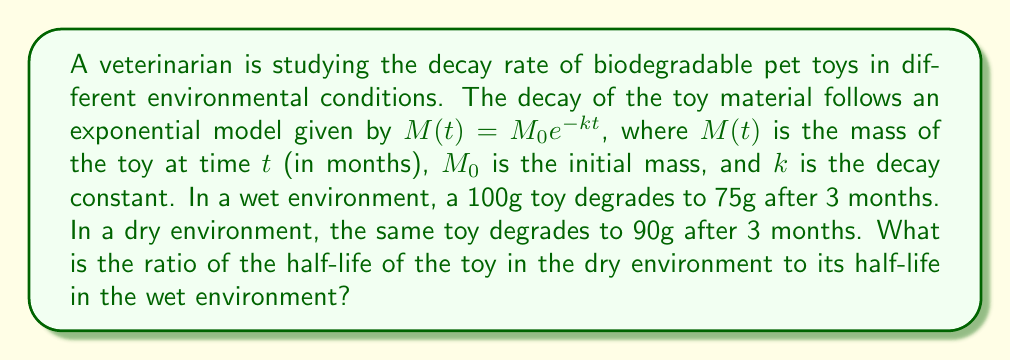Help me with this question. Let's approach this step-by-step:

1) First, we need to find the decay constants ($k$) for both environments.

2) For the wet environment:
   $75 = 100e^{-k_w \cdot 3}$
   $\ln(0.75) = -3k_w$
   $k_w = -\frac{\ln(0.75)}{3} \approx 0.0963$

3) For the dry environment:
   $90 = 100e^{-k_d \cdot 3}$
   $\ln(0.9) = -3k_d$
   $k_d = -\frac{\ln(0.9)}{3} \approx 0.0351$

4) The half-life ($t_{1/2}$) is the time it takes for half of the material to decay. It's given by:
   $t_{1/2} = \frac{\ln(2)}{k}$

5) For the wet environment:
   $t_{1/2,w} = \frac{\ln(2)}{k_w} \approx 7.20$ months

6) For the dry environment:
   $t_{1/2,d} = \frac{\ln(2)}{k_d} \approx 19.75$ months

7) The ratio of half-lives (dry to wet) is:
   $\frac{t_{1/2,d}}{t_{1/2,w}} = \frac{19.75}{7.20} \approx 2.74$
Answer: 2.74 